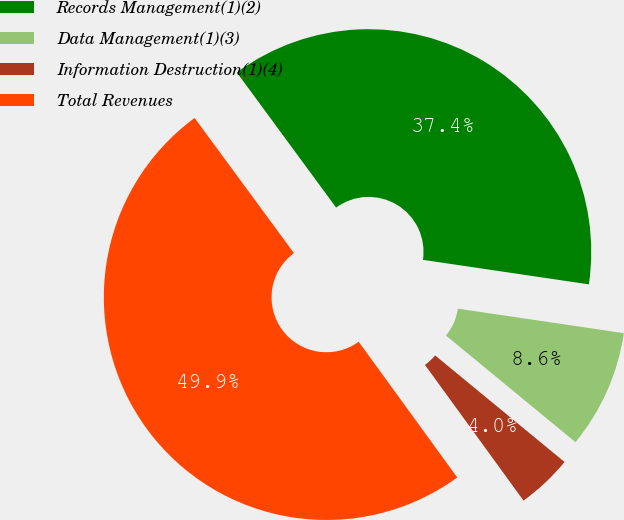Convert chart. <chart><loc_0><loc_0><loc_500><loc_500><pie_chart><fcel>Records Management(1)(2)<fcel>Data Management(1)(3)<fcel>Information Destruction(1)(4)<fcel>Total Revenues<nl><fcel>37.42%<fcel>8.63%<fcel>4.04%<fcel>49.91%<nl></chart> 